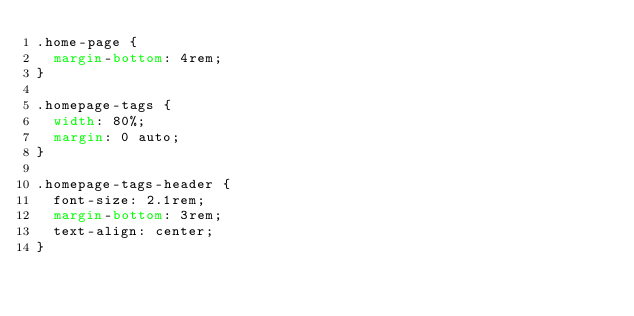<code> <loc_0><loc_0><loc_500><loc_500><_CSS_>.home-page {
	margin-bottom: 4rem;
}

.homepage-tags {
	width: 80%;
	margin: 0 auto;
}

.homepage-tags-header {
	font-size: 2.1rem;
	margin-bottom: 3rem;
	text-align: center;
}
</code> 